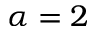Convert formula to latex. <formula><loc_0><loc_0><loc_500><loc_500>\alpha = 2</formula> 